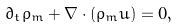Convert formula to latex. <formula><loc_0><loc_0><loc_500><loc_500>\partial _ { t } \rho _ { m } + \nabla \cdot ( \rho _ { m } { u } ) = 0 ,</formula> 